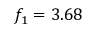Convert formula to latex. <formula><loc_0><loc_0><loc_500><loc_500>f _ { 1 } = 3 . 6 8</formula> 